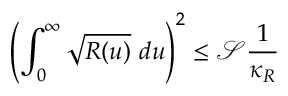Convert formula to latex. <formula><loc_0><loc_0><loc_500><loc_500>\left ( \int _ { 0 } ^ { \infty } \sqrt { R ( u ) } d u \right ) ^ { 2 } \leq \ m a t h s c r { S } \frac { 1 } { \kappa _ { R } }</formula> 